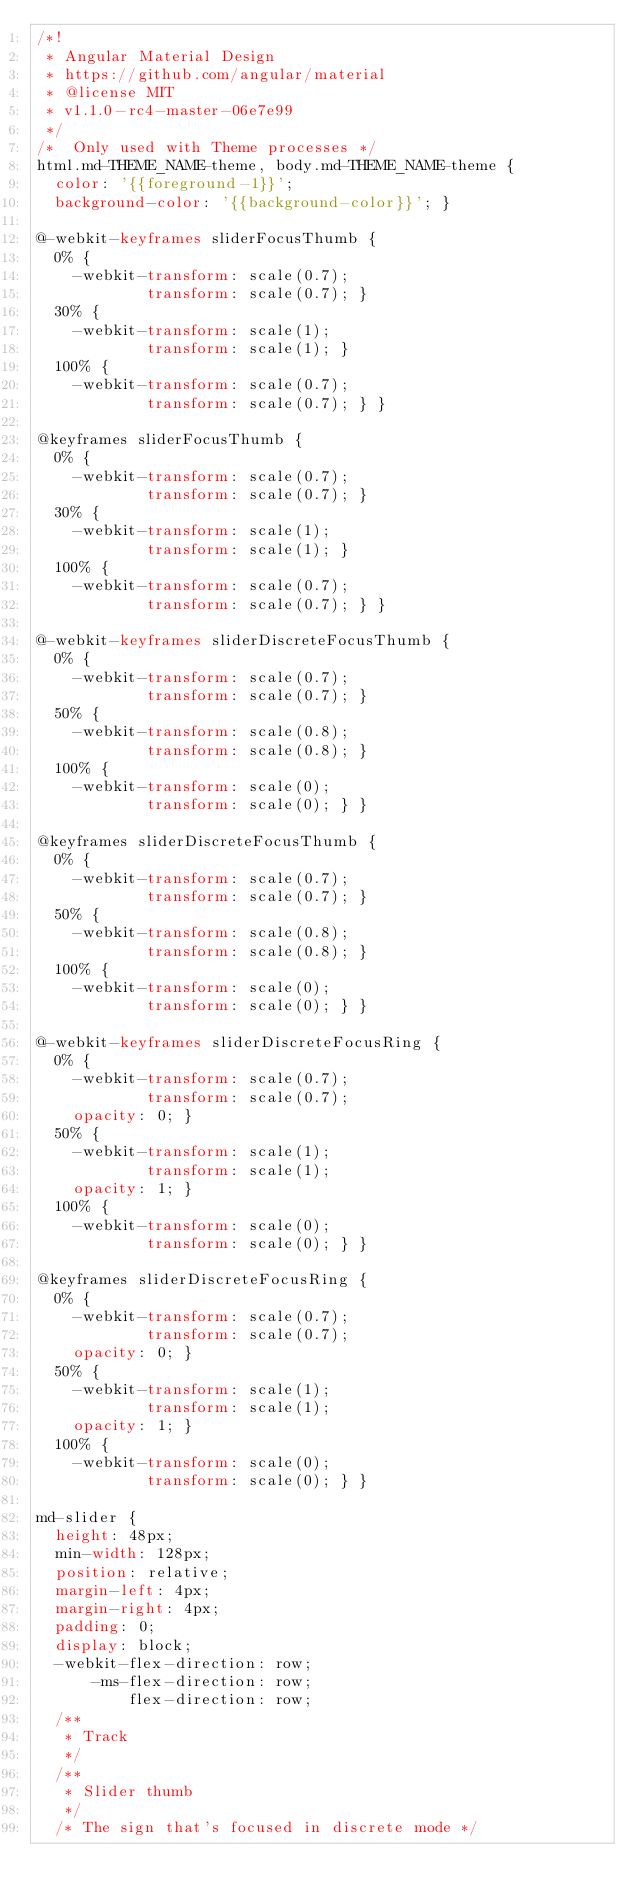<code> <loc_0><loc_0><loc_500><loc_500><_CSS_>/*!
 * Angular Material Design
 * https://github.com/angular/material
 * @license MIT
 * v1.1.0-rc4-master-06e7e99
 */
/*  Only used with Theme processes */
html.md-THEME_NAME-theme, body.md-THEME_NAME-theme {
  color: '{{foreground-1}}';
  background-color: '{{background-color}}'; }

@-webkit-keyframes sliderFocusThumb {
  0% {
    -webkit-transform: scale(0.7);
            transform: scale(0.7); }
  30% {
    -webkit-transform: scale(1);
            transform: scale(1); }
  100% {
    -webkit-transform: scale(0.7);
            transform: scale(0.7); } }

@keyframes sliderFocusThumb {
  0% {
    -webkit-transform: scale(0.7);
            transform: scale(0.7); }
  30% {
    -webkit-transform: scale(1);
            transform: scale(1); }
  100% {
    -webkit-transform: scale(0.7);
            transform: scale(0.7); } }

@-webkit-keyframes sliderDiscreteFocusThumb {
  0% {
    -webkit-transform: scale(0.7);
            transform: scale(0.7); }
  50% {
    -webkit-transform: scale(0.8);
            transform: scale(0.8); }
  100% {
    -webkit-transform: scale(0);
            transform: scale(0); } }

@keyframes sliderDiscreteFocusThumb {
  0% {
    -webkit-transform: scale(0.7);
            transform: scale(0.7); }
  50% {
    -webkit-transform: scale(0.8);
            transform: scale(0.8); }
  100% {
    -webkit-transform: scale(0);
            transform: scale(0); } }

@-webkit-keyframes sliderDiscreteFocusRing {
  0% {
    -webkit-transform: scale(0.7);
            transform: scale(0.7);
    opacity: 0; }
  50% {
    -webkit-transform: scale(1);
            transform: scale(1);
    opacity: 1; }
  100% {
    -webkit-transform: scale(0);
            transform: scale(0); } }

@keyframes sliderDiscreteFocusRing {
  0% {
    -webkit-transform: scale(0.7);
            transform: scale(0.7);
    opacity: 0; }
  50% {
    -webkit-transform: scale(1);
            transform: scale(1);
    opacity: 1; }
  100% {
    -webkit-transform: scale(0);
            transform: scale(0); } }

md-slider {
  height: 48px;
  min-width: 128px;
  position: relative;
  margin-left: 4px;
  margin-right: 4px;
  padding: 0;
  display: block;
  -webkit-flex-direction: row;
      -ms-flex-direction: row;
          flex-direction: row;
  /**
   * Track
   */
  /**
   * Slider thumb
   */
  /* The sign that's focused in discrete mode */</code> 